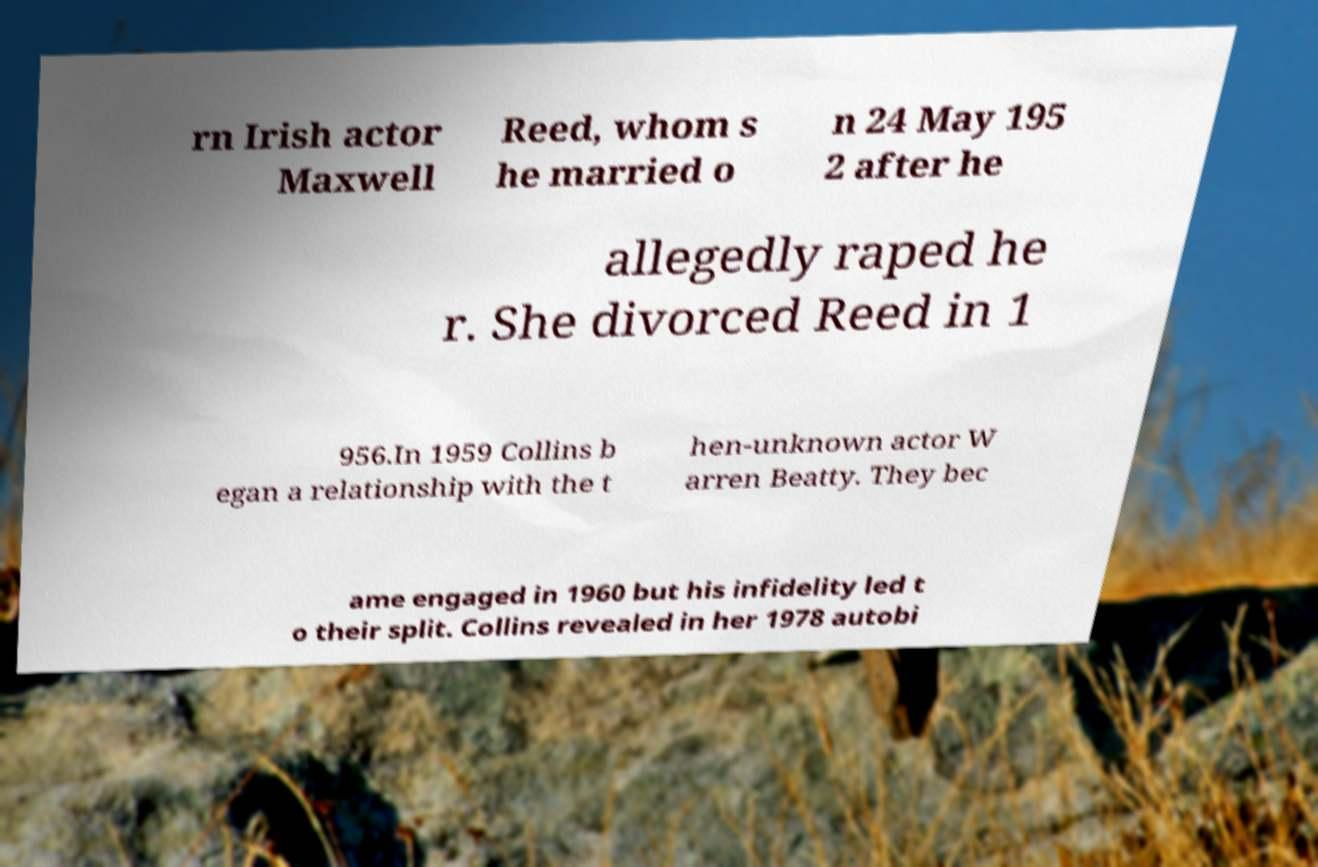Can you read and provide the text displayed in the image?This photo seems to have some interesting text. Can you extract and type it out for me? rn Irish actor Maxwell Reed, whom s he married o n 24 May 195 2 after he allegedly raped he r. She divorced Reed in 1 956.In 1959 Collins b egan a relationship with the t hen-unknown actor W arren Beatty. They bec ame engaged in 1960 but his infidelity led t o their split. Collins revealed in her 1978 autobi 